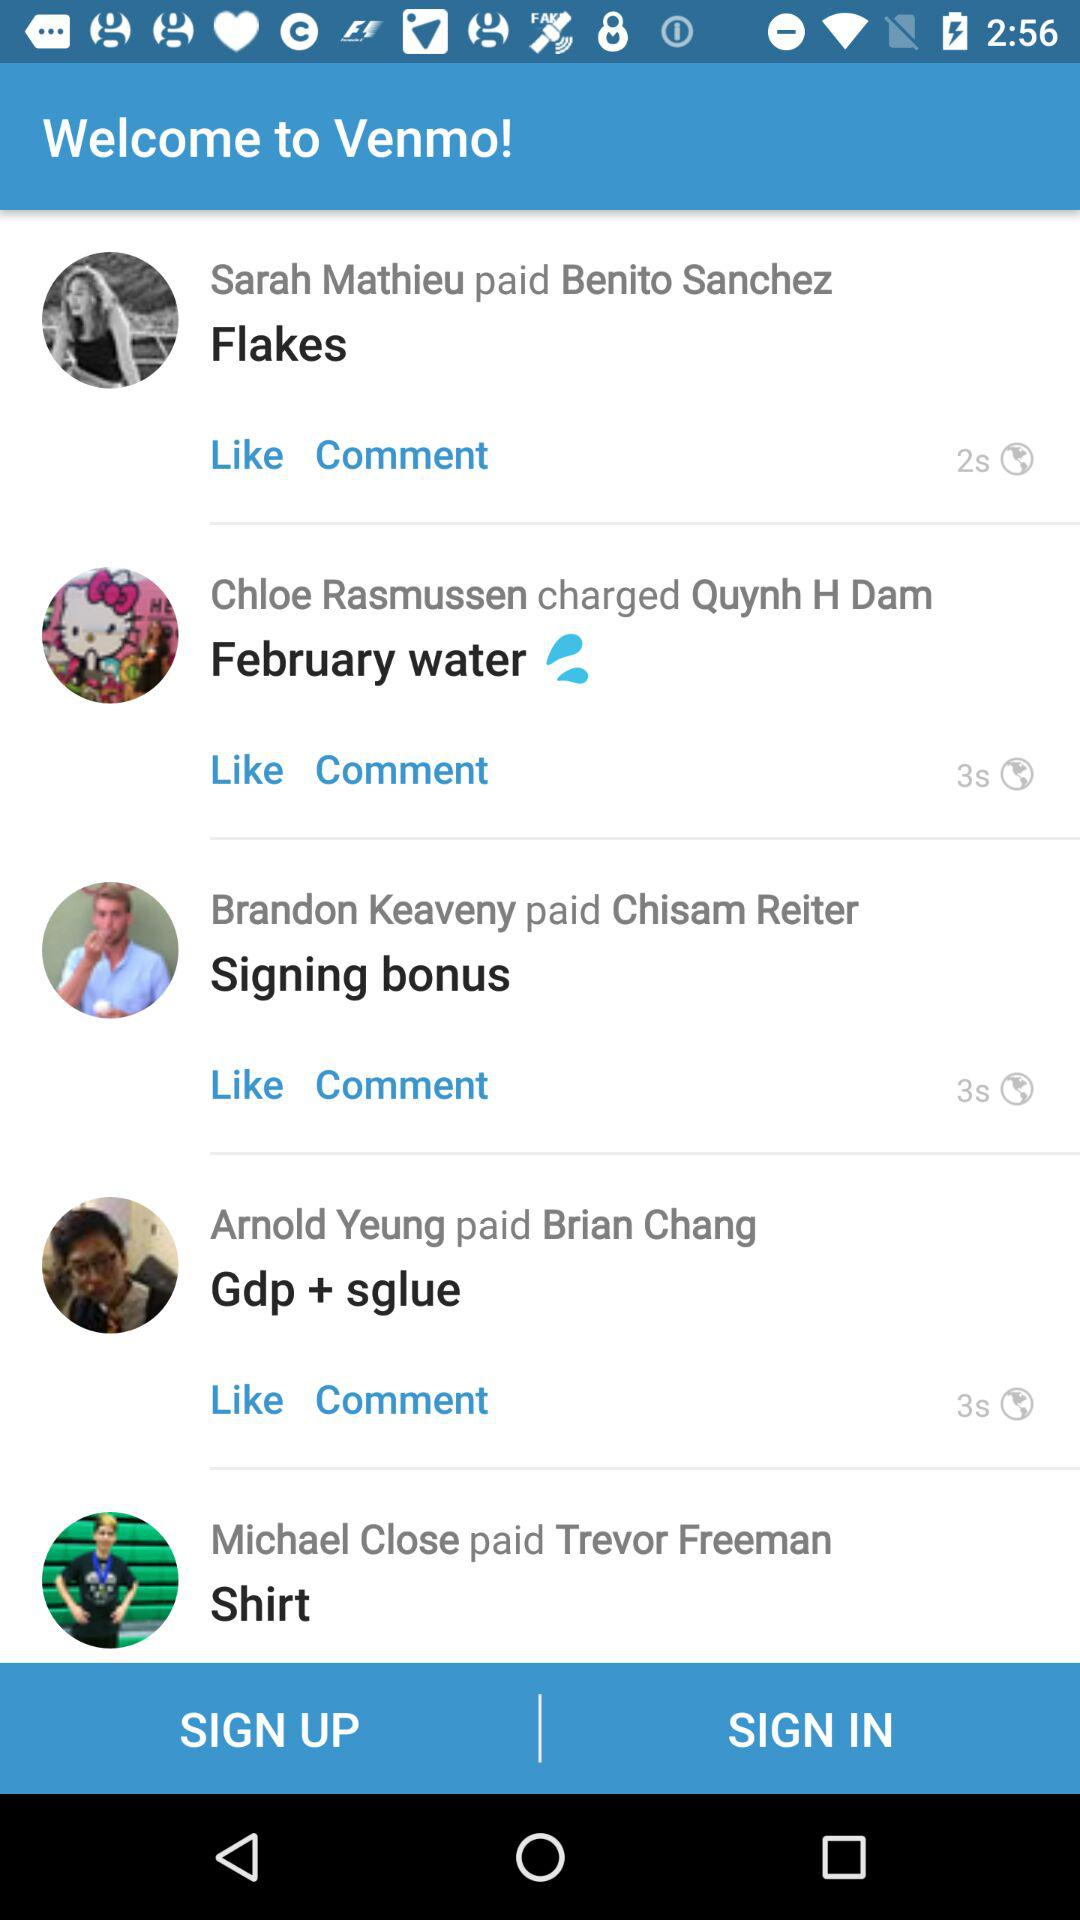Who paid Chisam Reiter? Chisam Reiter was paid by Brandon Keaveny. 